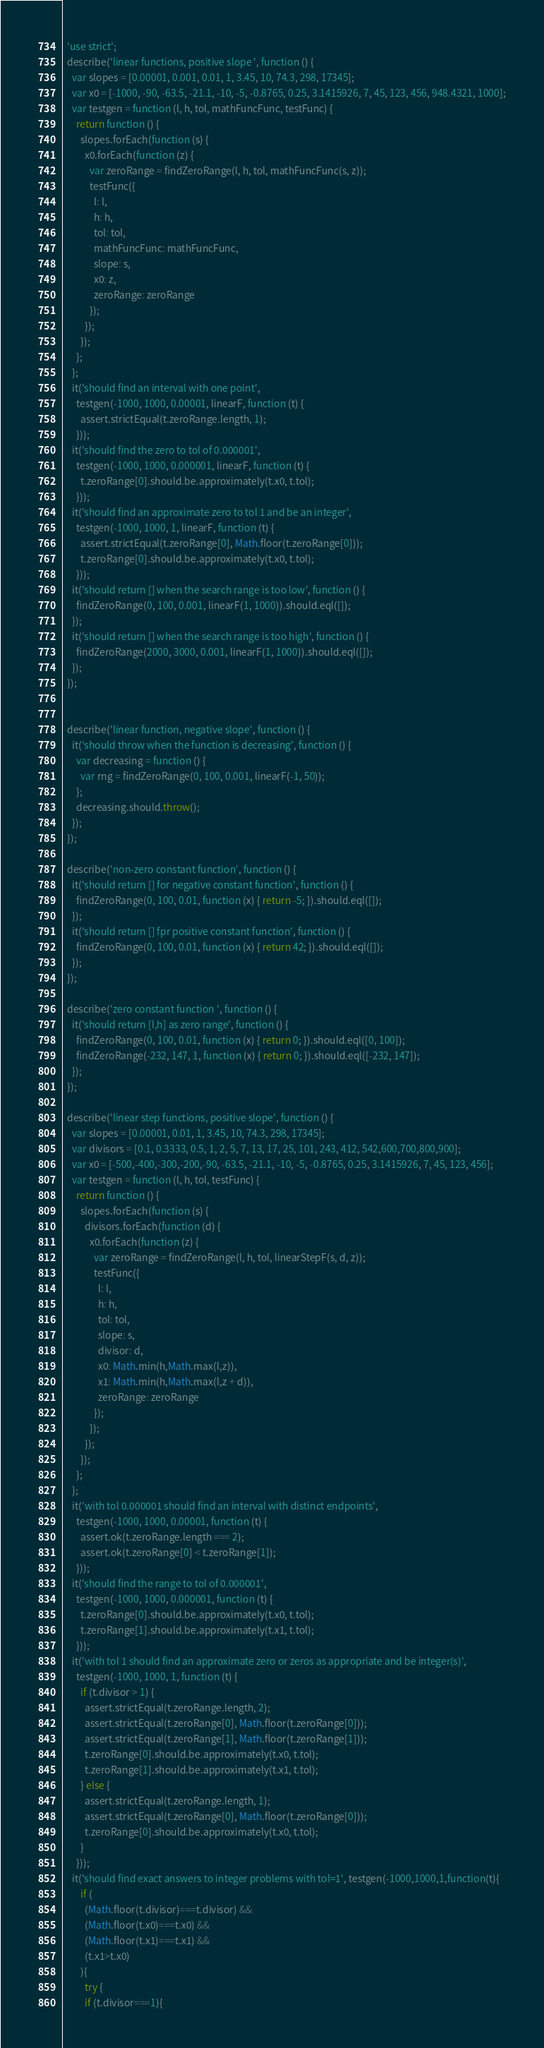Convert code to text. <code><loc_0><loc_0><loc_500><loc_500><_JavaScript_>  'use strict';
  describe('linear functions, positive slope ', function () {
    var slopes = [0.00001, 0.001, 0.01, 1, 3.45, 10, 74.3, 298, 17345];
    var x0 = [-1000, -90, -63.5, -21.1, -10, -5, -0.8765, 0.25, 3.1415926, 7, 45, 123, 456, 948.4321, 1000];
    var testgen = function (l, h, tol, mathFuncFunc, testFunc) {
      return function () {
        slopes.forEach(function (s) {
          x0.forEach(function (z) {
            var zeroRange = findZeroRange(l, h, tol, mathFuncFunc(s, z));
            testFunc({
              l: l,
              h: h,
              tol: tol,
              mathFuncFunc: mathFuncFunc,
              slope: s,
              x0: z,
              zeroRange: zeroRange
            });
          });
        });
      };
    };
    it('should find an interval with one point',
      testgen(-1000, 1000, 0.00001, linearF, function (t) {
        assert.strictEqual(t.zeroRange.length, 1);
      }));
    it('should find the zero to tol of 0.000001',
      testgen(-1000, 1000, 0.000001, linearF, function (t) {
        t.zeroRange[0].should.be.approximately(t.x0, t.tol);
      }));
    it('should find an approximate zero to tol 1 and be an integer',
      testgen(-1000, 1000, 1, linearF, function (t) {
        assert.strictEqual(t.zeroRange[0], Math.floor(t.zeroRange[0]));
        t.zeroRange[0].should.be.approximately(t.x0, t.tol);
      }));
    it('should return [] when the search range is too low', function () {
      findZeroRange(0, 100, 0.001, linearF(1, 1000)).should.eql([]);
    });
    it('should return [] when the search range is too high', function () {
      findZeroRange(2000, 3000, 0.001, linearF(1, 1000)).should.eql([]);
    });
  });


  describe('linear function, negative slope', function () {
    it('should throw when the function is decreasing', function () {
      var decreasing = function () {
        var rng = findZeroRange(0, 100, 0.001, linearF(-1, 50));
      };
      decreasing.should.throw();
    });
  });

  describe('non-zero constant function', function () {
    it('should return [] for negative constant function', function () {
      findZeroRange(0, 100, 0.01, function (x) { return -5; }).should.eql([]);
    });
    it('should return [] fpr positive constant function', function () {
      findZeroRange(0, 100, 0.01, function (x) { return 42; }).should.eql([]);
    });
  });

  describe('zero constant function ', function () {
    it('should return [l,h] as zero range', function () {
      findZeroRange(0, 100, 0.01, function (x) { return 0; }).should.eql([0, 100]);
      findZeroRange(-232, 147, 1, function (x) { return 0; }).should.eql([-232, 147]);
    });
  });

  describe('linear step functions, positive slope', function () {
    var slopes = [0.00001, 0.01, 1, 3.45, 10, 74.3, 298, 17345];
    var divisors = [0.1, 0.3333, 0.5, 1, 2, 5, 7, 13, 17, 25, 101, 243, 412, 542,600,700,800,900];
    var x0 = [-500,-400,-300,-200,-90, -63.5, -21.1, -10, -5, -0.8765, 0.25, 3.1415926, 7, 45, 123, 456];
    var testgen = function (l, h, tol, testFunc) {
      return function () {
        slopes.forEach(function (s) {
          divisors.forEach(function (d) {
            x0.forEach(function (z) {
              var zeroRange = findZeroRange(l, h, tol, linearStepF(s, d, z));
              testFunc({
                l: l,
                h: h,
                tol: tol,
                slope: s,
                divisor: d,
                x0: Math.min(h,Math.max(l,z)),
                x1: Math.min(h,Math.max(l,z + d)),
                zeroRange: zeroRange
              });
            });
          });
        });
      };
    };
    it('with tol 0.000001 should find an interval with distinct endpoints',
      testgen(-1000, 1000, 0.00001, function (t) {
        assert.ok(t.zeroRange.length === 2);
        assert.ok(t.zeroRange[0] < t.zeroRange[1]);
      }));
    it('should find the range to tol of 0.000001',
      testgen(-1000, 1000, 0.000001, function (t) {
        t.zeroRange[0].should.be.approximately(t.x0, t.tol);
        t.zeroRange[1].should.be.approximately(t.x1, t.tol);
      }));
    it('with tol 1 should find an approximate zero or zeros as appropriate and be integer(s)',
      testgen(-1000, 1000, 1, function (t) {
        if (t.divisor > 1) {
          assert.strictEqual(t.zeroRange.length, 2);
          assert.strictEqual(t.zeroRange[0], Math.floor(t.zeroRange[0]));
          assert.strictEqual(t.zeroRange[1], Math.floor(t.zeroRange[1]));
          t.zeroRange[0].should.be.approximately(t.x0, t.tol);
          t.zeroRange[1].should.be.approximately(t.x1, t.tol);
        } else {
          assert.strictEqual(t.zeroRange.length, 1);
          assert.strictEqual(t.zeroRange[0], Math.floor(t.zeroRange[0]));
          t.zeroRange[0].should.be.approximately(t.x0, t.tol);
        }
      }));
    it('should find exact answers to integer problems with tol=1', testgen(-1000,1000,1,function(t){
        if (
          (Math.floor(t.divisor)===t.divisor) &&
          (Math.floor(t.x0)===t.x0) &&
          (Math.floor(t.x1)===t.x1) &&
          (t.x1>t.x0)
        ){
          try {
          if (t.divisor===1){</code> 